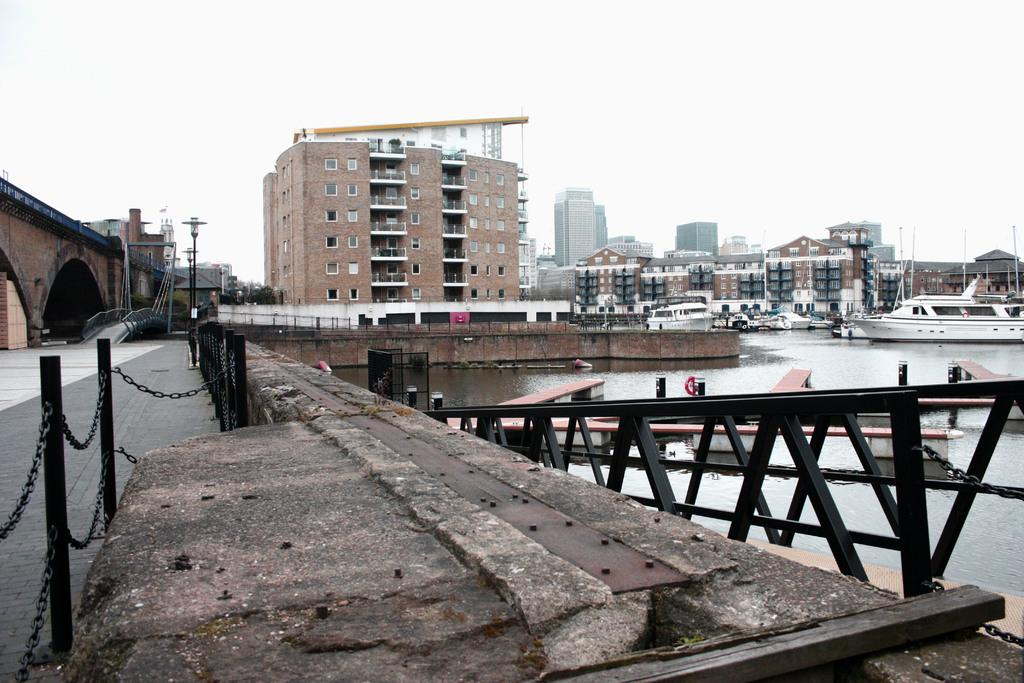What structure can be seen in the image? There is a bridge in the image. What is located near the bridge? There is a water surface beside the bridge. What is on the water surface? There are boats on the water surface. What can be seen in the distance in the image? There are buildings in the background of the image. What type of porter is responsible for the distribution of goods in the image? There is no porter or distribution of goods present in the image. What day is it in the image? The day cannot be determined from the image, as it does not provide any information about the time or date. 